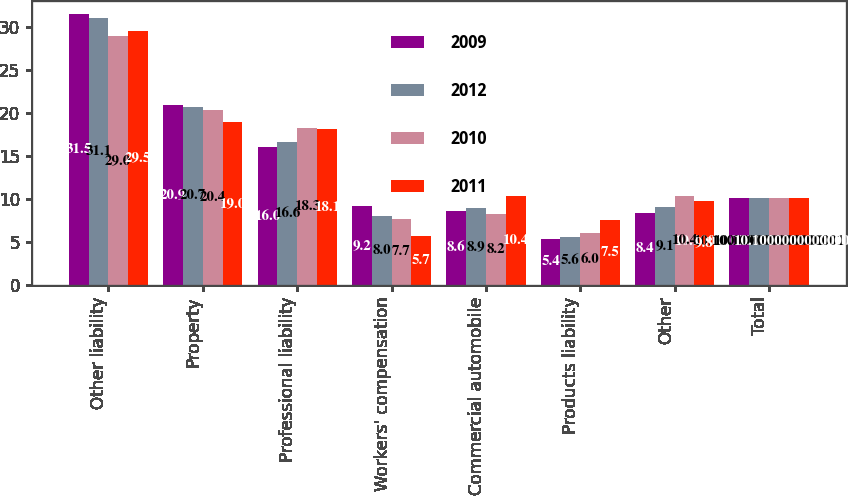Convert chart to OTSL. <chart><loc_0><loc_0><loc_500><loc_500><stacked_bar_chart><ecel><fcel>Other liability<fcel>Property<fcel>Professional liability<fcel>Workers' compensation<fcel>Commercial automobile<fcel>Products liability<fcel>Other<fcel>Total<nl><fcel>2009<fcel>31.5<fcel>20.9<fcel>16<fcel>9.2<fcel>8.6<fcel>5.4<fcel>8.4<fcel>10.1<nl><fcel>2012<fcel>31.1<fcel>20.7<fcel>16.6<fcel>8<fcel>8.9<fcel>5.6<fcel>9.1<fcel>10.1<nl><fcel>2010<fcel>29<fcel>20.4<fcel>18.3<fcel>7.7<fcel>8.2<fcel>6<fcel>10.4<fcel>10.1<nl><fcel>2011<fcel>29.5<fcel>19<fcel>18.1<fcel>5.7<fcel>10.4<fcel>7.5<fcel>9.8<fcel>10.1<nl></chart> 